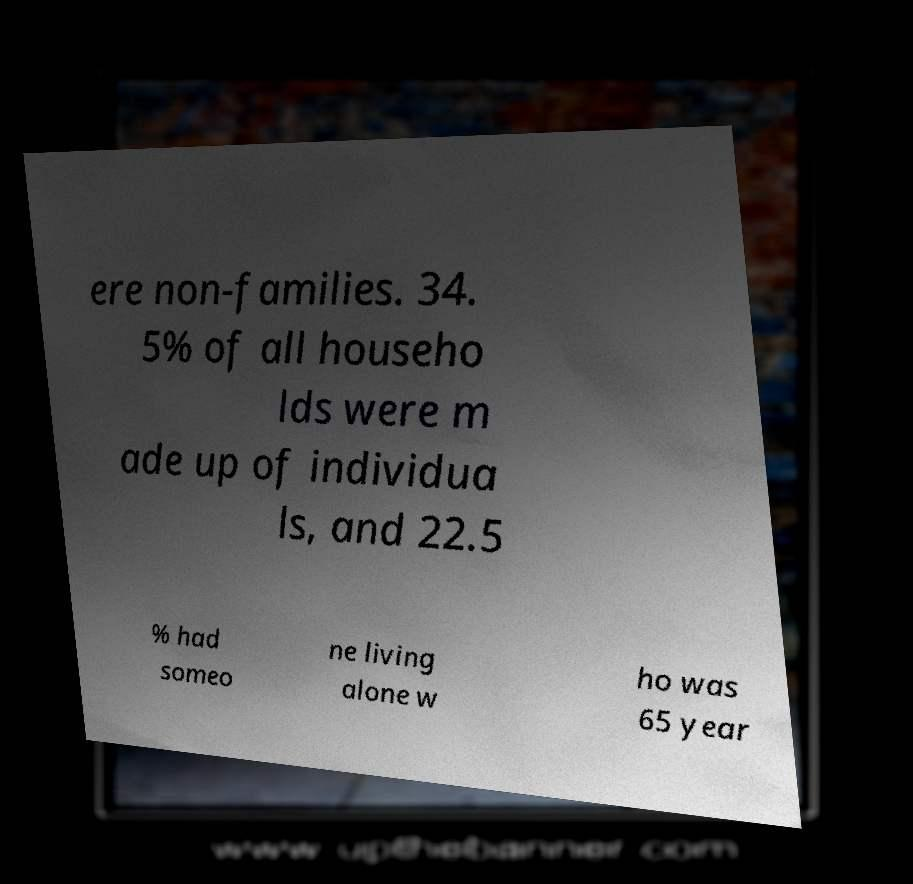Please read and relay the text visible in this image. What does it say? ere non-families. 34. 5% of all househo lds were m ade up of individua ls, and 22.5 % had someo ne living alone w ho was 65 year 